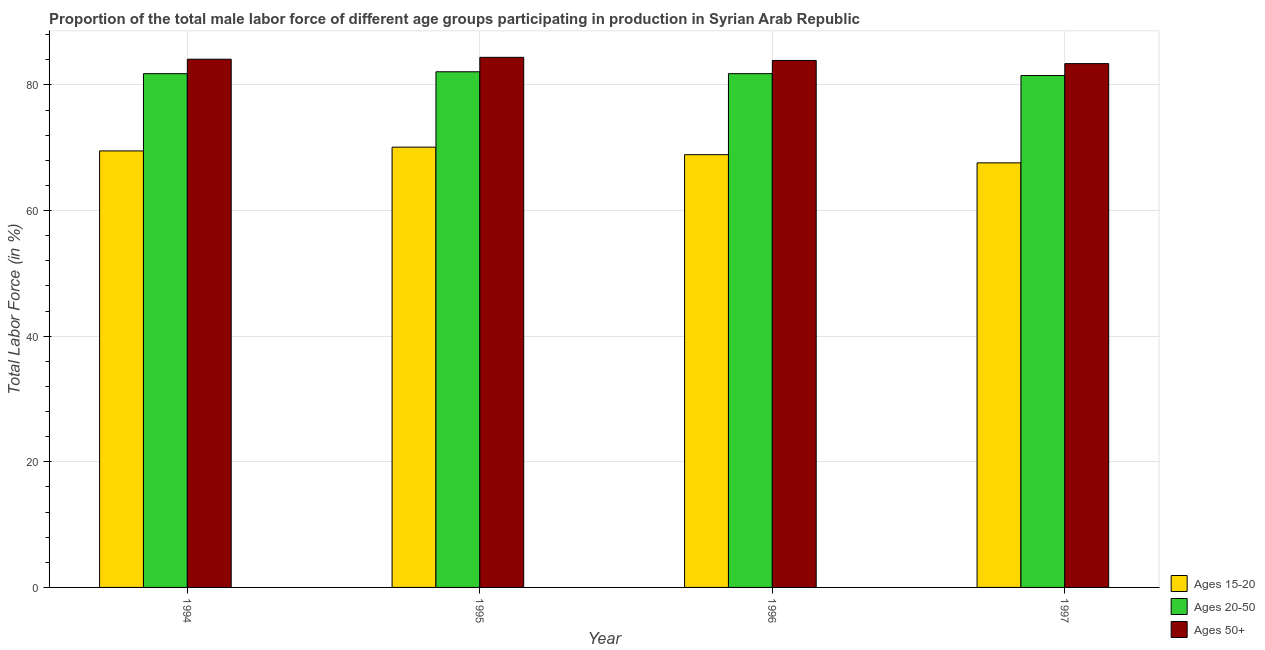What is the percentage of male labor force above age 50 in 1997?
Give a very brief answer. 83.4. Across all years, what is the maximum percentage of male labor force within the age group 15-20?
Keep it short and to the point. 70.1. Across all years, what is the minimum percentage of male labor force within the age group 15-20?
Offer a terse response. 67.6. In which year was the percentage of male labor force above age 50 minimum?
Provide a succinct answer. 1997. What is the total percentage of male labor force within the age group 15-20 in the graph?
Ensure brevity in your answer.  276.1. What is the difference between the percentage of male labor force above age 50 in 1995 and that in 1997?
Your answer should be compact. 1. What is the difference between the percentage of male labor force above age 50 in 1997 and the percentage of male labor force within the age group 20-50 in 1994?
Your response must be concise. -0.7. What is the average percentage of male labor force within the age group 15-20 per year?
Offer a terse response. 69.02. In the year 1997, what is the difference between the percentage of male labor force within the age group 15-20 and percentage of male labor force within the age group 20-50?
Offer a terse response. 0. In how many years, is the percentage of male labor force above age 50 greater than 32 %?
Your answer should be very brief. 4. What is the ratio of the percentage of male labor force above age 50 in 1995 to that in 1997?
Your response must be concise. 1.01. Is the difference between the percentage of male labor force above age 50 in 1996 and 1997 greater than the difference between the percentage of male labor force within the age group 20-50 in 1996 and 1997?
Offer a very short reply. No. What is the difference between the highest and the second highest percentage of male labor force above age 50?
Offer a terse response. 0.3. In how many years, is the percentage of male labor force within the age group 15-20 greater than the average percentage of male labor force within the age group 15-20 taken over all years?
Offer a terse response. 2. What does the 2nd bar from the left in 1997 represents?
Your answer should be compact. Ages 20-50. What does the 2nd bar from the right in 1996 represents?
Keep it short and to the point. Ages 20-50. How many bars are there?
Your response must be concise. 12. Are all the bars in the graph horizontal?
Keep it short and to the point. No. What is the difference between two consecutive major ticks on the Y-axis?
Your answer should be very brief. 20. Are the values on the major ticks of Y-axis written in scientific E-notation?
Offer a very short reply. No. Where does the legend appear in the graph?
Your answer should be very brief. Bottom right. How many legend labels are there?
Make the answer very short. 3. How are the legend labels stacked?
Make the answer very short. Vertical. What is the title of the graph?
Make the answer very short. Proportion of the total male labor force of different age groups participating in production in Syrian Arab Republic. Does "Gaseous fuel" appear as one of the legend labels in the graph?
Make the answer very short. No. What is the label or title of the X-axis?
Provide a succinct answer. Year. What is the label or title of the Y-axis?
Your answer should be compact. Total Labor Force (in %). What is the Total Labor Force (in %) of Ages 15-20 in 1994?
Ensure brevity in your answer.  69.5. What is the Total Labor Force (in %) of Ages 20-50 in 1994?
Your answer should be compact. 81.8. What is the Total Labor Force (in %) in Ages 50+ in 1994?
Offer a terse response. 84.1. What is the Total Labor Force (in %) in Ages 15-20 in 1995?
Make the answer very short. 70.1. What is the Total Labor Force (in %) of Ages 20-50 in 1995?
Provide a succinct answer. 82.1. What is the Total Labor Force (in %) of Ages 50+ in 1995?
Offer a terse response. 84.4. What is the Total Labor Force (in %) in Ages 15-20 in 1996?
Your answer should be compact. 68.9. What is the Total Labor Force (in %) in Ages 20-50 in 1996?
Offer a terse response. 81.8. What is the Total Labor Force (in %) in Ages 50+ in 1996?
Ensure brevity in your answer.  83.9. What is the Total Labor Force (in %) in Ages 15-20 in 1997?
Your response must be concise. 67.6. What is the Total Labor Force (in %) in Ages 20-50 in 1997?
Your response must be concise. 81.5. What is the Total Labor Force (in %) of Ages 50+ in 1997?
Provide a succinct answer. 83.4. Across all years, what is the maximum Total Labor Force (in %) in Ages 15-20?
Provide a short and direct response. 70.1. Across all years, what is the maximum Total Labor Force (in %) of Ages 20-50?
Provide a short and direct response. 82.1. Across all years, what is the maximum Total Labor Force (in %) of Ages 50+?
Give a very brief answer. 84.4. Across all years, what is the minimum Total Labor Force (in %) in Ages 15-20?
Keep it short and to the point. 67.6. Across all years, what is the minimum Total Labor Force (in %) of Ages 20-50?
Ensure brevity in your answer.  81.5. Across all years, what is the minimum Total Labor Force (in %) of Ages 50+?
Provide a short and direct response. 83.4. What is the total Total Labor Force (in %) of Ages 15-20 in the graph?
Make the answer very short. 276.1. What is the total Total Labor Force (in %) in Ages 20-50 in the graph?
Keep it short and to the point. 327.2. What is the total Total Labor Force (in %) of Ages 50+ in the graph?
Provide a succinct answer. 335.8. What is the difference between the Total Labor Force (in %) of Ages 15-20 in 1994 and that in 1995?
Provide a succinct answer. -0.6. What is the difference between the Total Labor Force (in %) in Ages 20-50 in 1994 and that in 1995?
Your answer should be compact. -0.3. What is the difference between the Total Labor Force (in %) in Ages 20-50 in 1994 and that in 1996?
Keep it short and to the point. 0. What is the difference between the Total Labor Force (in %) of Ages 50+ in 1994 and that in 1996?
Make the answer very short. 0.2. What is the difference between the Total Labor Force (in %) in Ages 20-50 in 1994 and that in 1997?
Make the answer very short. 0.3. What is the difference between the Total Labor Force (in %) of Ages 50+ in 1994 and that in 1997?
Your answer should be compact. 0.7. What is the difference between the Total Labor Force (in %) of Ages 20-50 in 1995 and that in 1996?
Offer a very short reply. 0.3. What is the difference between the Total Labor Force (in %) of Ages 50+ in 1995 and that in 1997?
Your answer should be very brief. 1. What is the difference between the Total Labor Force (in %) in Ages 15-20 in 1996 and that in 1997?
Offer a very short reply. 1.3. What is the difference between the Total Labor Force (in %) of Ages 20-50 in 1996 and that in 1997?
Your answer should be very brief. 0.3. What is the difference between the Total Labor Force (in %) of Ages 15-20 in 1994 and the Total Labor Force (in %) of Ages 50+ in 1995?
Ensure brevity in your answer.  -14.9. What is the difference between the Total Labor Force (in %) in Ages 15-20 in 1994 and the Total Labor Force (in %) in Ages 50+ in 1996?
Your answer should be very brief. -14.4. What is the difference between the Total Labor Force (in %) of Ages 20-50 in 1994 and the Total Labor Force (in %) of Ages 50+ in 1996?
Your answer should be compact. -2.1. What is the difference between the Total Labor Force (in %) of Ages 15-20 in 1994 and the Total Labor Force (in %) of Ages 20-50 in 1997?
Make the answer very short. -12. What is the difference between the Total Labor Force (in %) of Ages 15-20 in 1995 and the Total Labor Force (in %) of Ages 20-50 in 1996?
Give a very brief answer. -11.7. What is the difference between the Total Labor Force (in %) in Ages 20-50 in 1995 and the Total Labor Force (in %) in Ages 50+ in 1996?
Your response must be concise. -1.8. What is the difference between the Total Labor Force (in %) of Ages 15-20 in 1995 and the Total Labor Force (in %) of Ages 50+ in 1997?
Keep it short and to the point. -13.3. What is the difference between the Total Labor Force (in %) in Ages 20-50 in 1995 and the Total Labor Force (in %) in Ages 50+ in 1997?
Provide a short and direct response. -1.3. What is the difference between the Total Labor Force (in %) in Ages 15-20 in 1996 and the Total Labor Force (in %) in Ages 20-50 in 1997?
Provide a succinct answer. -12.6. What is the difference between the Total Labor Force (in %) of Ages 15-20 in 1996 and the Total Labor Force (in %) of Ages 50+ in 1997?
Your answer should be very brief. -14.5. What is the average Total Labor Force (in %) in Ages 15-20 per year?
Your answer should be compact. 69.03. What is the average Total Labor Force (in %) of Ages 20-50 per year?
Your answer should be very brief. 81.8. What is the average Total Labor Force (in %) in Ages 50+ per year?
Give a very brief answer. 83.95. In the year 1994, what is the difference between the Total Labor Force (in %) in Ages 15-20 and Total Labor Force (in %) in Ages 20-50?
Keep it short and to the point. -12.3. In the year 1994, what is the difference between the Total Labor Force (in %) of Ages 15-20 and Total Labor Force (in %) of Ages 50+?
Your answer should be very brief. -14.6. In the year 1994, what is the difference between the Total Labor Force (in %) of Ages 20-50 and Total Labor Force (in %) of Ages 50+?
Make the answer very short. -2.3. In the year 1995, what is the difference between the Total Labor Force (in %) in Ages 15-20 and Total Labor Force (in %) in Ages 20-50?
Make the answer very short. -12. In the year 1995, what is the difference between the Total Labor Force (in %) in Ages 15-20 and Total Labor Force (in %) in Ages 50+?
Your response must be concise. -14.3. In the year 1995, what is the difference between the Total Labor Force (in %) of Ages 20-50 and Total Labor Force (in %) of Ages 50+?
Ensure brevity in your answer.  -2.3. In the year 1996, what is the difference between the Total Labor Force (in %) of Ages 15-20 and Total Labor Force (in %) of Ages 20-50?
Your response must be concise. -12.9. In the year 1996, what is the difference between the Total Labor Force (in %) in Ages 20-50 and Total Labor Force (in %) in Ages 50+?
Keep it short and to the point. -2.1. In the year 1997, what is the difference between the Total Labor Force (in %) of Ages 15-20 and Total Labor Force (in %) of Ages 50+?
Give a very brief answer. -15.8. What is the ratio of the Total Labor Force (in %) in Ages 15-20 in 1994 to that in 1996?
Your response must be concise. 1.01. What is the ratio of the Total Labor Force (in %) in Ages 50+ in 1994 to that in 1996?
Provide a succinct answer. 1. What is the ratio of the Total Labor Force (in %) in Ages 15-20 in 1994 to that in 1997?
Your response must be concise. 1.03. What is the ratio of the Total Labor Force (in %) of Ages 20-50 in 1994 to that in 1997?
Give a very brief answer. 1. What is the ratio of the Total Labor Force (in %) in Ages 50+ in 1994 to that in 1997?
Give a very brief answer. 1.01. What is the ratio of the Total Labor Force (in %) in Ages 15-20 in 1995 to that in 1996?
Give a very brief answer. 1.02. What is the ratio of the Total Labor Force (in %) in Ages 20-50 in 1995 to that in 1996?
Your answer should be compact. 1. What is the ratio of the Total Labor Force (in %) in Ages 20-50 in 1995 to that in 1997?
Your response must be concise. 1.01. What is the ratio of the Total Labor Force (in %) in Ages 50+ in 1995 to that in 1997?
Your response must be concise. 1.01. What is the ratio of the Total Labor Force (in %) of Ages 15-20 in 1996 to that in 1997?
Keep it short and to the point. 1.02. What is the ratio of the Total Labor Force (in %) of Ages 20-50 in 1996 to that in 1997?
Your answer should be very brief. 1. What is the difference between the highest and the second highest Total Labor Force (in %) in Ages 15-20?
Ensure brevity in your answer.  0.6. What is the difference between the highest and the second highest Total Labor Force (in %) in Ages 50+?
Ensure brevity in your answer.  0.3. What is the difference between the highest and the lowest Total Labor Force (in %) of Ages 50+?
Your answer should be very brief. 1. 